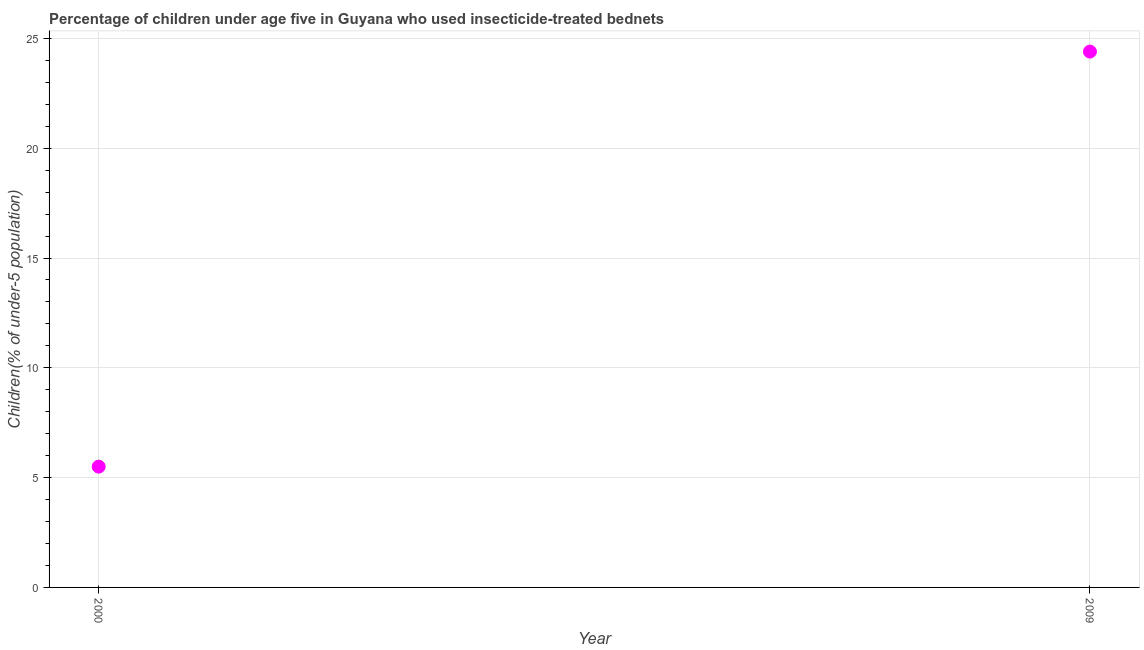Across all years, what is the maximum percentage of children who use of insecticide-treated bed nets?
Give a very brief answer. 24.4. Across all years, what is the minimum percentage of children who use of insecticide-treated bed nets?
Your answer should be very brief. 5.5. In which year was the percentage of children who use of insecticide-treated bed nets maximum?
Offer a terse response. 2009. What is the sum of the percentage of children who use of insecticide-treated bed nets?
Give a very brief answer. 29.9. What is the difference between the percentage of children who use of insecticide-treated bed nets in 2000 and 2009?
Your answer should be compact. -18.9. What is the average percentage of children who use of insecticide-treated bed nets per year?
Keep it short and to the point. 14.95. What is the median percentage of children who use of insecticide-treated bed nets?
Your response must be concise. 14.95. In how many years, is the percentage of children who use of insecticide-treated bed nets greater than 23 %?
Keep it short and to the point. 1. Do a majority of the years between 2009 and 2000 (inclusive) have percentage of children who use of insecticide-treated bed nets greater than 8 %?
Your answer should be compact. No. What is the ratio of the percentage of children who use of insecticide-treated bed nets in 2000 to that in 2009?
Your response must be concise. 0.23. Is the percentage of children who use of insecticide-treated bed nets in 2000 less than that in 2009?
Offer a terse response. Yes. In how many years, is the percentage of children who use of insecticide-treated bed nets greater than the average percentage of children who use of insecticide-treated bed nets taken over all years?
Offer a terse response. 1. Does the percentage of children who use of insecticide-treated bed nets monotonically increase over the years?
Ensure brevity in your answer.  Yes. How many years are there in the graph?
Provide a short and direct response. 2. What is the difference between two consecutive major ticks on the Y-axis?
Offer a terse response. 5. Are the values on the major ticks of Y-axis written in scientific E-notation?
Provide a short and direct response. No. Does the graph contain any zero values?
Provide a succinct answer. No. Does the graph contain grids?
Ensure brevity in your answer.  Yes. What is the title of the graph?
Your answer should be compact. Percentage of children under age five in Guyana who used insecticide-treated bednets. What is the label or title of the X-axis?
Offer a very short reply. Year. What is the label or title of the Y-axis?
Make the answer very short. Children(% of under-5 population). What is the Children(% of under-5 population) in 2000?
Provide a succinct answer. 5.5. What is the Children(% of under-5 population) in 2009?
Your answer should be compact. 24.4. What is the difference between the Children(% of under-5 population) in 2000 and 2009?
Make the answer very short. -18.9. What is the ratio of the Children(% of under-5 population) in 2000 to that in 2009?
Your answer should be very brief. 0.23. 